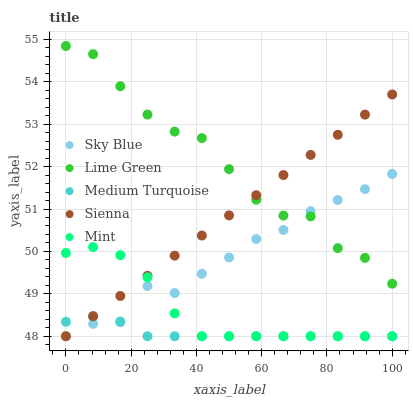Does Medium Turquoise have the minimum area under the curve?
Answer yes or no. Yes. Does Lime Green have the maximum area under the curve?
Answer yes or no. Yes. Does Sky Blue have the minimum area under the curve?
Answer yes or no. No. Does Sky Blue have the maximum area under the curve?
Answer yes or no. No. Is Sienna the smoothest?
Answer yes or no. Yes. Is Lime Green the roughest?
Answer yes or no. Yes. Is Sky Blue the smoothest?
Answer yes or no. No. Is Sky Blue the roughest?
Answer yes or no. No. Does Sienna have the lowest value?
Answer yes or no. Yes. Does Lime Green have the lowest value?
Answer yes or no. No. Does Lime Green have the highest value?
Answer yes or no. Yes. Does Sky Blue have the highest value?
Answer yes or no. No. Is Mint less than Lime Green?
Answer yes or no. Yes. Is Lime Green greater than Mint?
Answer yes or no. Yes. Does Sienna intersect Lime Green?
Answer yes or no. Yes. Is Sienna less than Lime Green?
Answer yes or no. No. Is Sienna greater than Lime Green?
Answer yes or no. No. Does Mint intersect Lime Green?
Answer yes or no. No. 